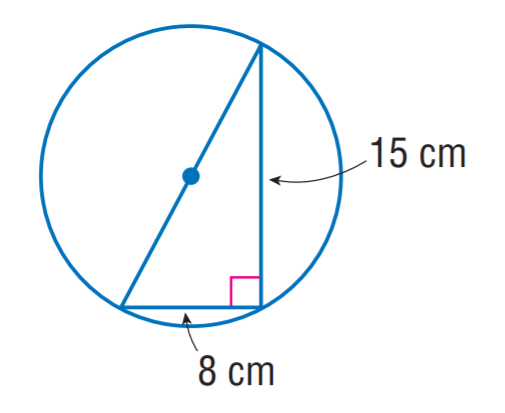Question: The triangle is inscribed into the circle. Find the exact circumference of the circle.
Choices:
A. 16 \pi
B. 17 \pi
C. 32 \pi
D. 34 \pi
Answer with the letter. Answer: B 